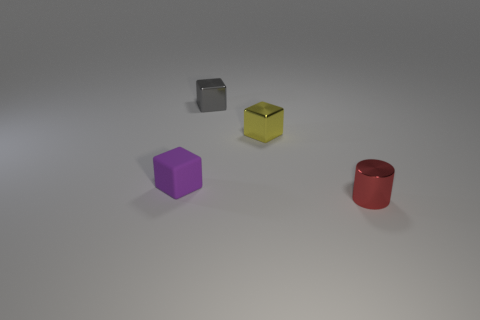There is a tiny block that is behind the tiny yellow metallic object; what is its material?
Keep it short and to the point. Metal. There is a cylinder that is the same size as the gray shiny object; what is its color?
Give a very brief answer. Red. How many other objects are the same shape as the tiny red thing?
Ensure brevity in your answer.  0. Is the size of the purple thing the same as the red cylinder?
Give a very brief answer. Yes. Is the number of small metallic cubes that are behind the tiny yellow metal thing greater than the number of tiny gray objects in front of the gray object?
Give a very brief answer. Yes. What number of other things are the same size as the gray thing?
Offer a terse response. 3. Do the tiny cube that is behind the yellow thing and the rubber block have the same color?
Provide a short and direct response. No. Are there more tiny shiny cylinders that are behind the tiny yellow object than small cubes?
Offer a terse response. No. Is there any other thing that is the same color as the tiny cylinder?
Your answer should be very brief. No. There is a small object in front of the small thing that is on the left side of the gray metallic cube; what is its shape?
Provide a short and direct response. Cylinder. 